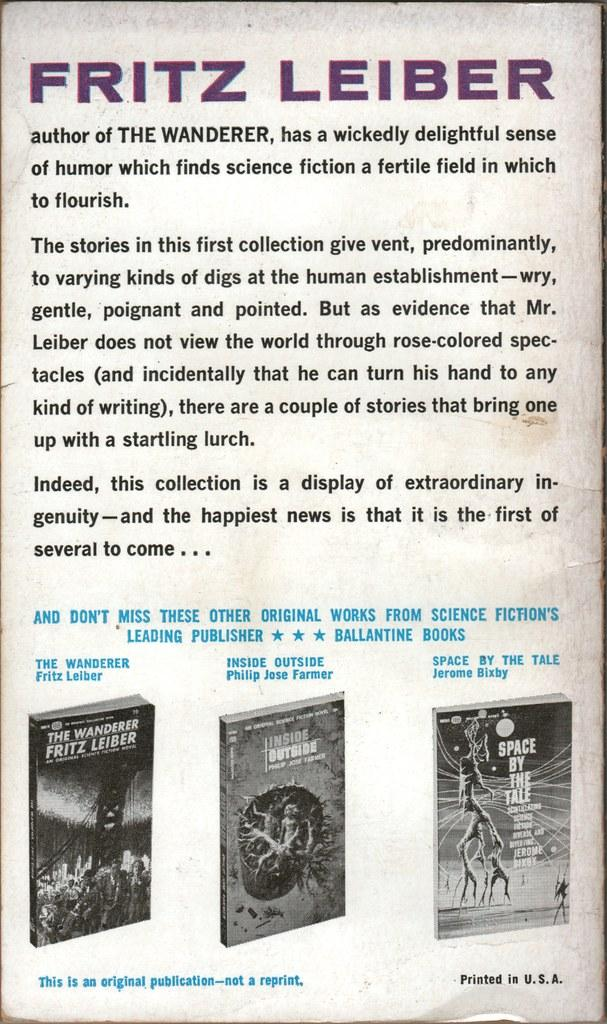<image>
Offer a succinct explanation of the picture presented. The back cover of a book written by Fritz Leiber. 